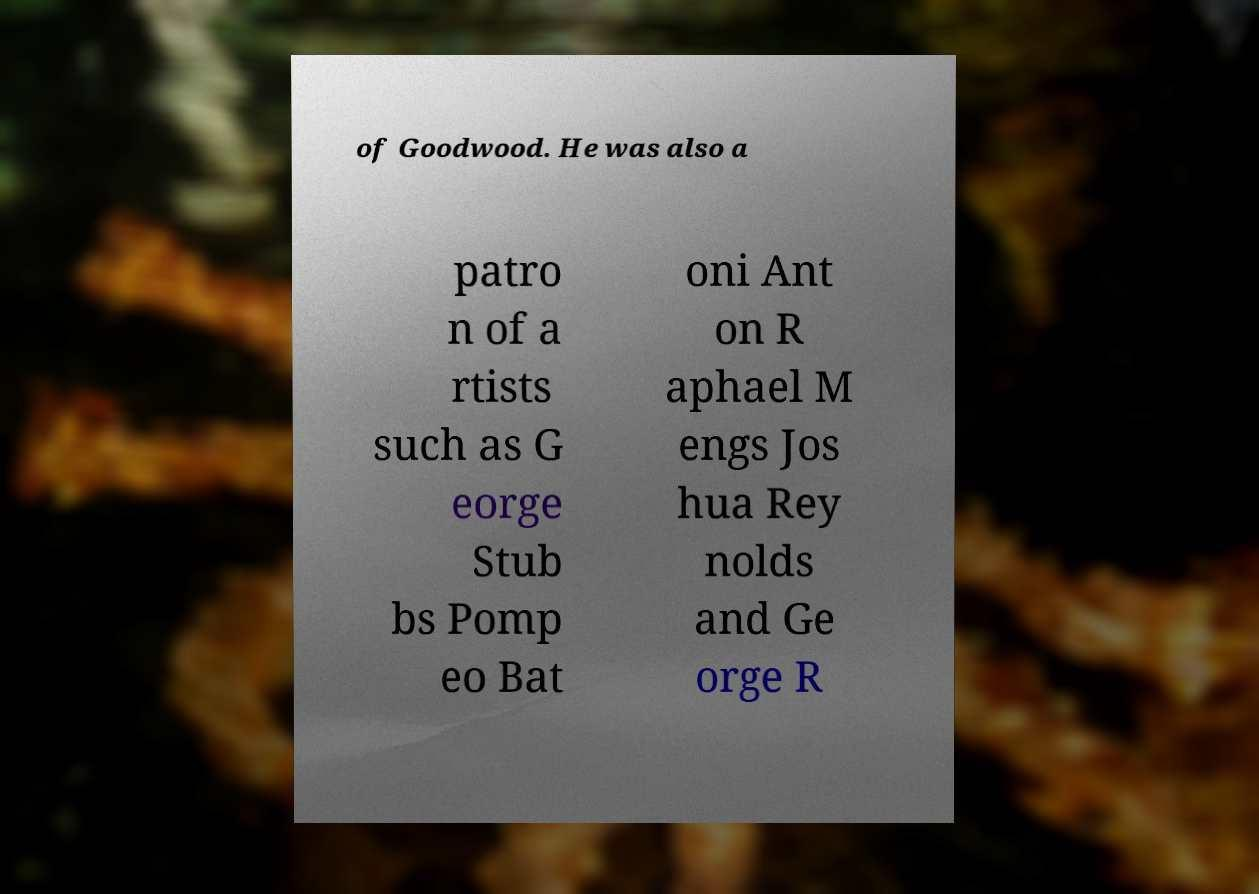Please identify and transcribe the text found in this image. of Goodwood. He was also a patro n of a rtists such as G eorge Stub bs Pomp eo Bat oni Ant on R aphael M engs Jos hua Rey nolds and Ge orge R 